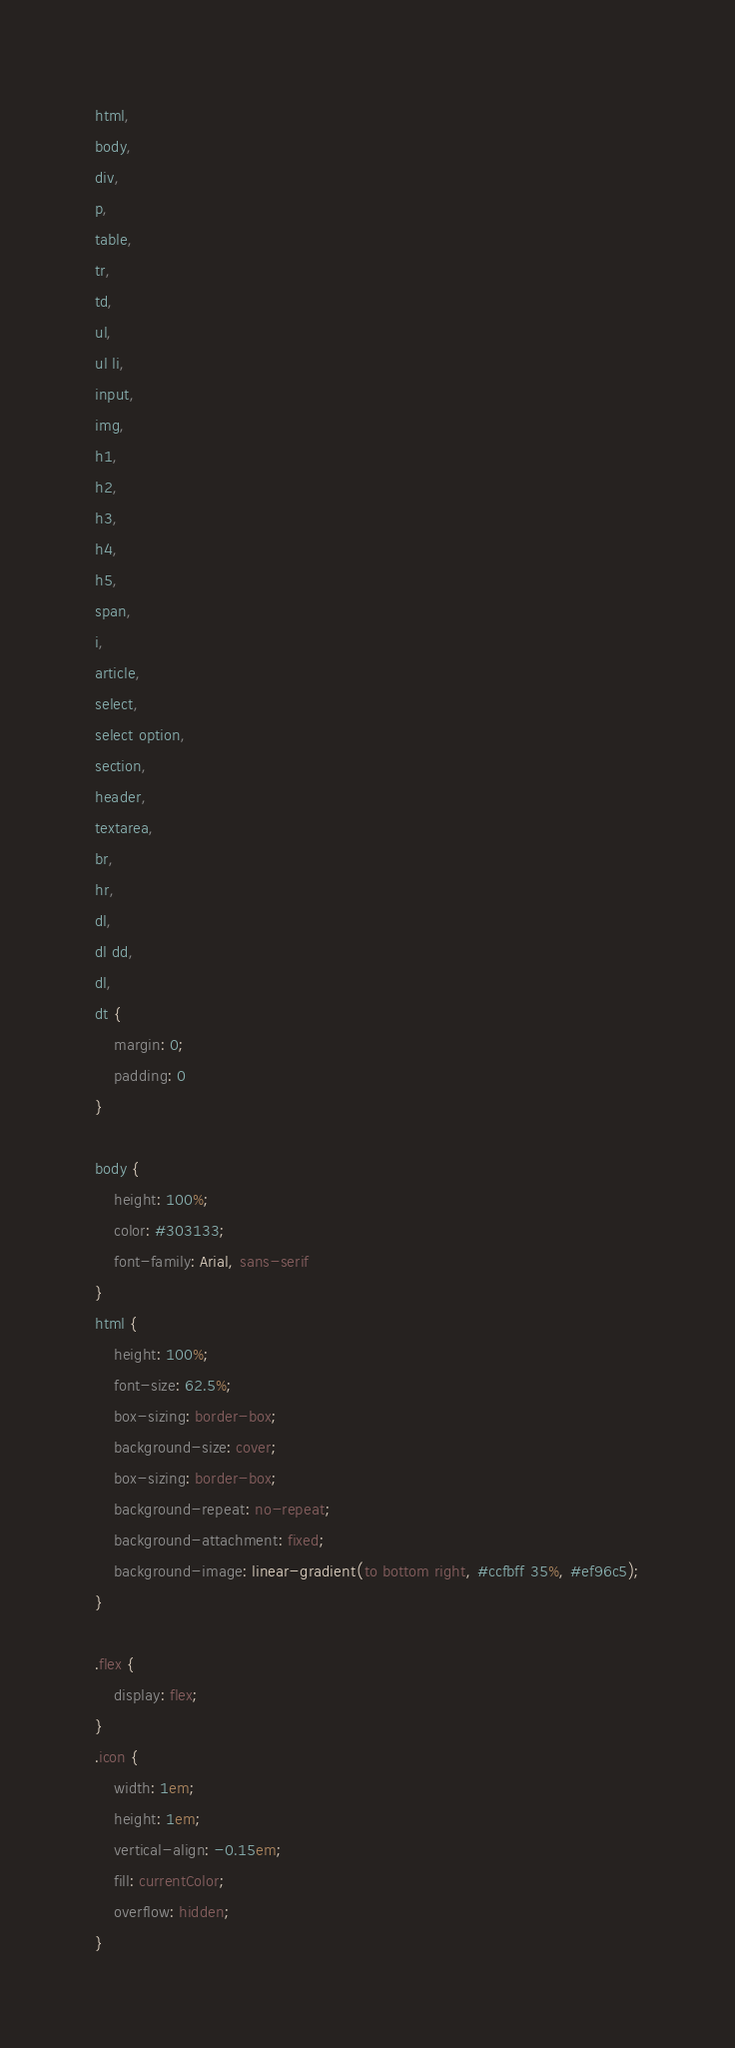Convert code to text. <code><loc_0><loc_0><loc_500><loc_500><_CSS_>html,
body,
div,
p,
table,
tr,
td,
ul,
ul li,
input,
img,
h1,
h2,
h3,
h4,
h5,
span,
i,
article,
select,
select option,
section,
header,
textarea,
br,
hr,
dl,
dl dd,
dl,
dt {
    margin: 0;
    padding: 0
}

body {
    height: 100%;
    color: #303133;
    font-family: Arial, sans-serif
}
html {
    height: 100%;
    font-size: 62.5%;
    box-sizing: border-box;
    background-size: cover;
    box-sizing: border-box;
    background-repeat: no-repeat;
    background-attachment: fixed;
    background-image: linear-gradient(to bottom right, #ccfbff 35%, #ef96c5);
}

.flex {
    display: flex;
}
.icon {
    width: 1em;
    height: 1em;
    vertical-align: -0.15em;
    fill: currentColor;
    overflow: hidden;
}</code> 